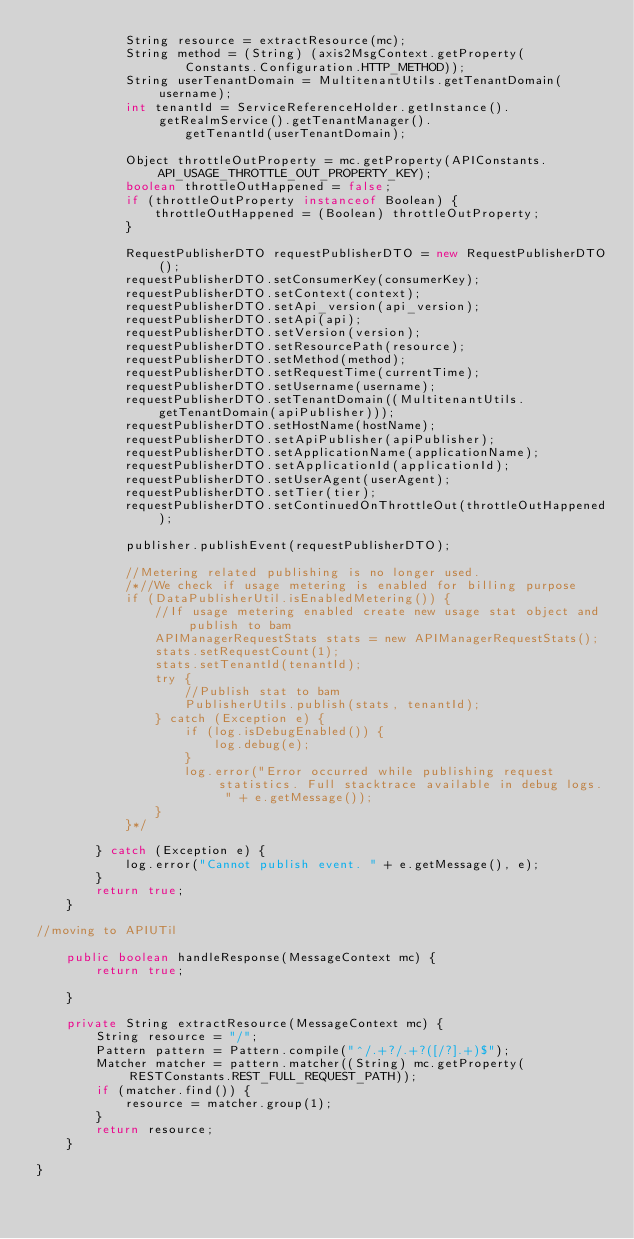Convert code to text. <code><loc_0><loc_0><loc_500><loc_500><_Java_>            String resource = extractResource(mc);
            String method = (String) (axis2MsgContext.getProperty(
                    Constants.Configuration.HTTP_METHOD));
            String userTenantDomain = MultitenantUtils.getTenantDomain(username);
            int tenantId = ServiceReferenceHolder.getInstance().getRealmService().getTenantManager().
                    getTenantId(userTenantDomain);

            Object throttleOutProperty = mc.getProperty(APIConstants.API_USAGE_THROTTLE_OUT_PROPERTY_KEY);
            boolean throttleOutHappened = false;
            if (throttleOutProperty instanceof Boolean) {
                throttleOutHappened = (Boolean) throttleOutProperty;
            }

            RequestPublisherDTO requestPublisherDTO = new RequestPublisherDTO();
            requestPublisherDTO.setConsumerKey(consumerKey);
            requestPublisherDTO.setContext(context);
            requestPublisherDTO.setApi_version(api_version);
            requestPublisherDTO.setApi(api);
            requestPublisherDTO.setVersion(version);
            requestPublisherDTO.setResourcePath(resource);
            requestPublisherDTO.setMethod(method);
            requestPublisherDTO.setRequestTime(currentTime);
            requestPublisherDTO.setUsername(username);
            requestPublisherDTO.setTenantDomain((MultitenantUtils.getTenantDomain(apiPublisher)));
            requestPublisherDTO.setHostName(hostName);
            requestPublisherDTO.setApiPublisher(apiPublisher);
            requestPublisherDTO.setApplicationName(applicationName);
            requestPublisherDTO.setApplicationId(applicationId);
            requestPublisherDTO.setUserAgent(userAgent);
            requestPublisherDTO.setTier(tier);
            requestPublisherDTO.setContinuedOnThrottleOut(throttleOutHappened);

            publisher.publishEvent(requestPublisherDTO);

            //Metering related publishing is no longer used.
            /*//We check if usage metering is enabled for billing purpose
            if (DataPublisherUtil.isEnabledMetering()) {
                //If usage metering enabled create new usage stat object and publish to bam
                APIManagerRequestStats stats = new APIManagerRequestStats();
                stats.setRequestCount(1);
                stats.setTenantId(tenantId);
                try {
                    //Publish stat to bam
                    PublisherUtils.publish(stats, tenantId);
                } catch (Exception e) {
                    if (log.isDebugEnabled()) {
                        log.debug(e);
                    }
                    log.error("Error occurred while publishing request statistics. Full stacktrace available in debug logs. " + e.getMessage());
                }
            }*/

        } catch (Exception e) {
            log.error("Cannot publish event. " + e.getMessage(), e);
        }
        return true;
    }

//moving to APIUTil

    public boolean handleResponse(MessageContext mc) {
        return true;

    }

    private String extractResource(MessageContext mc) {
        String resource = "/";
        Pattern pattern = Pattern.compile("^/.+?/.+?([/?].+)$");
        Matcher matcher = pattern.matcher((String) mc.getProperty(RESTConstants.REST_FULL_REQUEST_PATH));
        if (matcher.find()) {
            resource = matcher.group(1);
        }
        return resource;
    }

}
</code> 